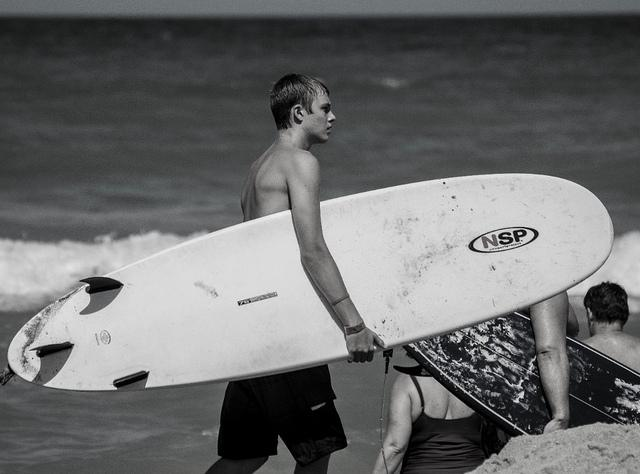What are the black triangular pieces on the board called? Please explain your reasoning. fins. A surfboard has projections to help with balance on one end. 